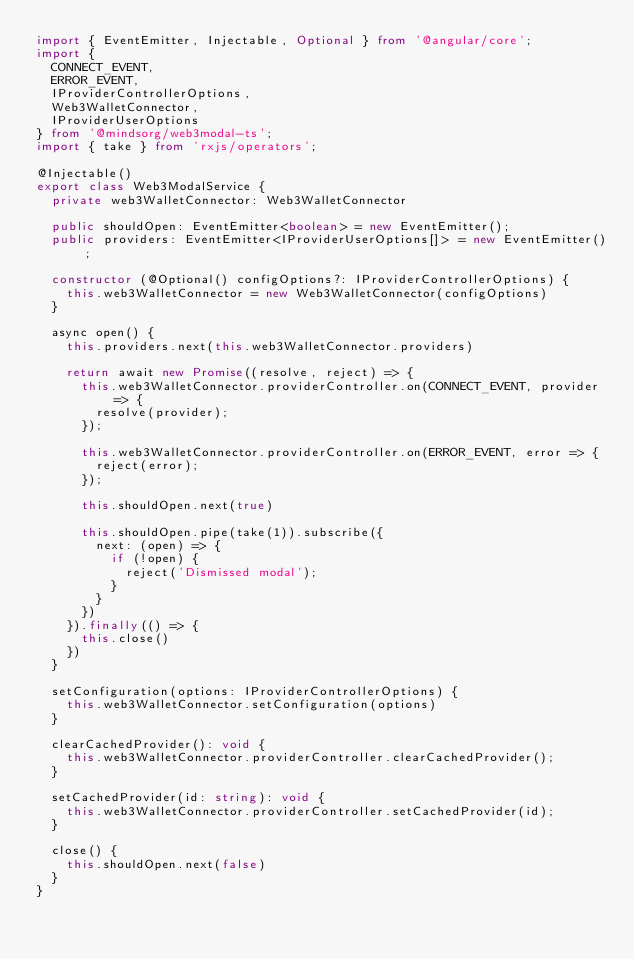<code> <loc_0><loc_0><loc_500><loc_500><_TypeScript_>import { EventEmitter, Injectable, Optional } from '@angular/core';
import {
  CONNECT_EVENT,
  ERROR_EVENT,
  IProviderControllerOptions,
  Web3WalletConnector,
  IProviderUserOptions
} from '@mindsorg/web3modal-ts';
import { take } from 'rxjs/operators';

@Injectable()
export class Web3ModalService {
  private web3WalletConnector: Web3WalletConnector

  public shouldOpen: EventEmitter<boolean> = new EventEmitter();
  public providers: EventEmitter<IProviderUserOptions[]> = new EventEmitter();

  constructor (@Optional() configOptions?: IProviderControllerOptions) {
    this.web3WalletConnector = new Web3WalletConnector(configOptions)
  }

  async open() {
    this.providers.next(this.web3WalletConnector.providers)

    return await new Promise((resolve, reject) => {
      this.web3WalletConnector.providerController.on(CONNECT_EVENT, provider => {
        resolve(provider);
      });
  
      this.web3WalletConnector.providerController.on(ERROR_EVENT, error => {
        reject(error);
      });

      this.shouldOpen.next(true)

      this.shouldOpen.pipe(take(1)).subscribe({
        next: (open) => {
          if (!open) {
            reject('Dismissed modal');
          }
        }
      })
    }).finally(() => {
      this.close()
    })
  }

  setConfiguration(options: IProviderControllerOptions) {
    this.web3WalletConnector.setConfiguration(options)
  }

  clearCachedProvider(): void {
    this.web3WalletConnector.providerController.clearCachedProvider();
  }

  setCachedProvider(id: string): void {
    this.web3WalletConnector.providerController.setCachedProvider(id);
  }

  close() {
    this.shouldOpen.next(false)
  }
}
</code> 